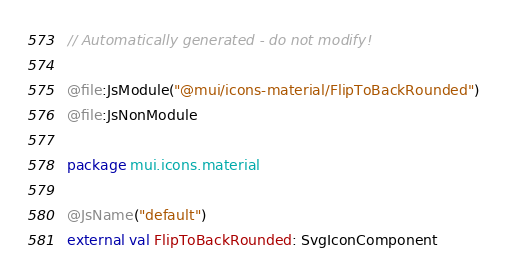Convert code to text. <code><loc_0><loc_0><loc_500><loc_500><_Kotlin_>// Automatically generated - do not modify!

@file:JsModule("@mui/icons-material/FlipToBackRounded")
@file:JsNonModule

package mui.icons.material

@JsName("default")
external val FlipToBackRounded: SvgIconComponent
</code> 